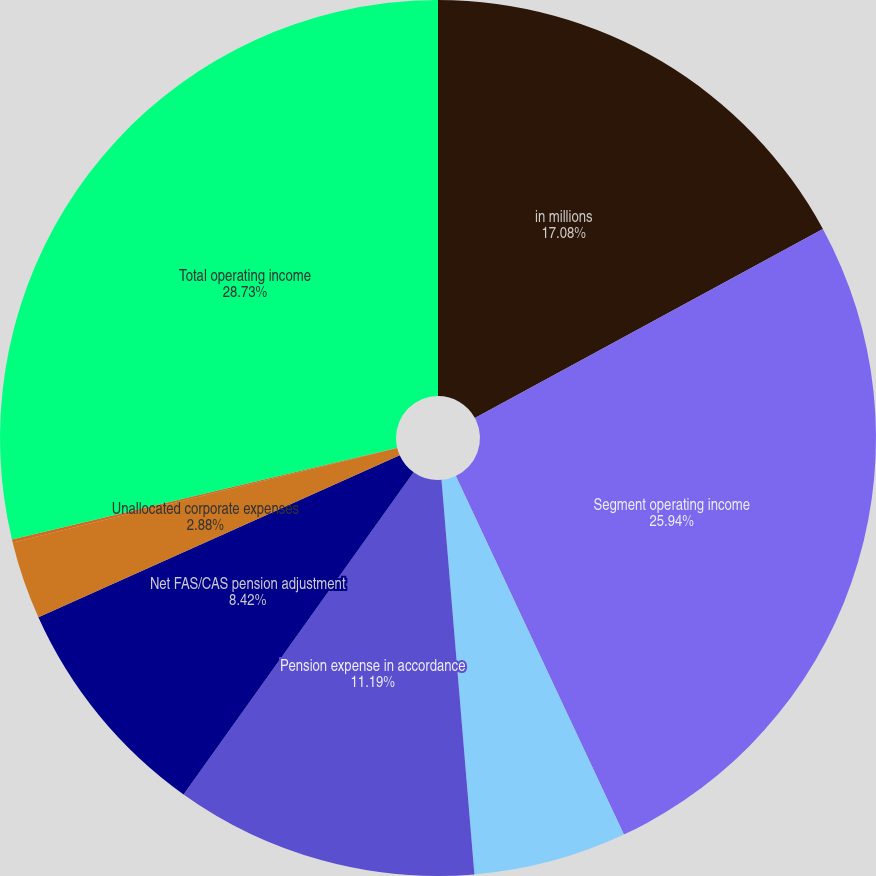Convert chart. <chart><loc_0><loc_0><loc_500><loc_500><pie_chart><fcel>in millions<fcel>Segment operating income<fcel>FAS pension expense in<fcel>Pension expense in accordance<fcel>Net FAS/CAS pension adjustment<fcel>Unallocated corporate expenses<fcel>Other<fcel>Total operating income<nl><fcel>17.08%<fcel>25.94%<fcel>5.65%<fcel>11.19%<fcel>8.42%<fcel>2.88%<fcel>0.11%<fcel>28.72%<nl></chart> 